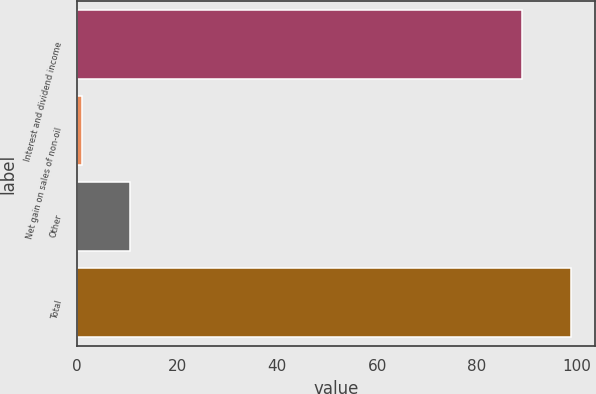Convert chart. <chart><loc_0><loc_0><loc_500><loc_500><bar_chart><fcel>Interest and dividend income<fcel>Net gain on sales of non-oil<fcel>Other<fcel>Total<nl><fcel>89<fcel>1<fcel>10.7<fcel>98.7<nl></chart> 